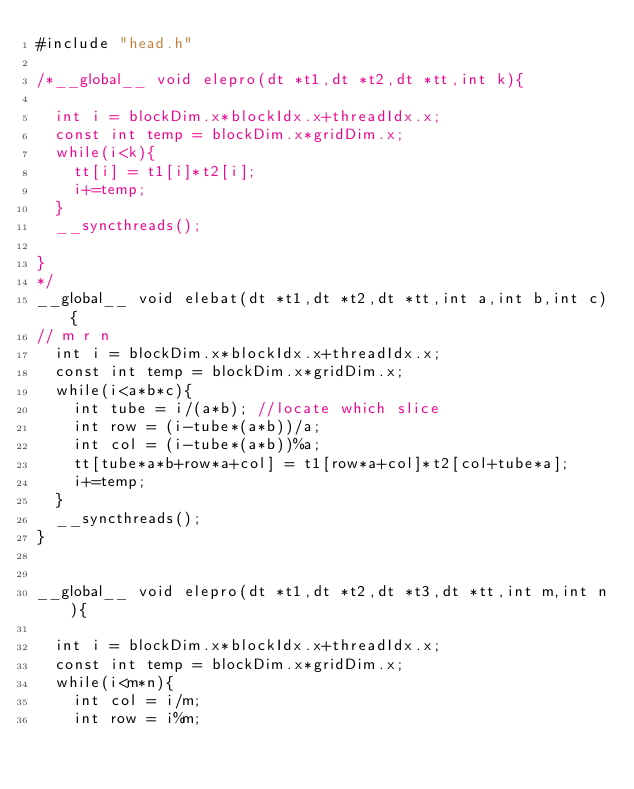<code> <loc_0><loc_0><loc_500><loc_500><_Cuda_>#include "head.h"

/*__global__ void elepro(dt *t1,dt *t2,dt *tt,int k){
	
	int i = blockDim.x*blockIdx.x+threadIdx.x;
	const int temp = blockDim.x*gridDim.x;
	while(i<k){
		tt[i] = t1[i]*t2[i];
		i+=temp;
	}
	__syncthreads();

}
*/
__global__ void elebat(dt *t1,dt *t2,dt *tt,int a,int b,int c){
// m r n
	int i = blockDim.x*blockIdx.x+threadIdx.x;
	const int temp = blockDim.x*gridDim.x;
	while(i<a*b*c){
		int tube = i/(a*b); //locate which slice
		int row = (i-tube*(a*b))/a;
		int col = (i-tube*(a*b))%a;
		tt[tube*a*b+row*a+col] = t1[row*a+col]*t2[col+tube*a];
		i+=temp;
	}
	__syncthreads();	
}


__global__ void elepro(dt *t1,dt *t2,dt *t3,dt *tt,int m,int n){
	
	int i = blockDim.x*blockIdx.x+threadIdx.x;
	const int temp = blockDim.x*gridDim.x;
	while(i<m*n){
		int col = i/m;
		int row = i%m;	</code> 